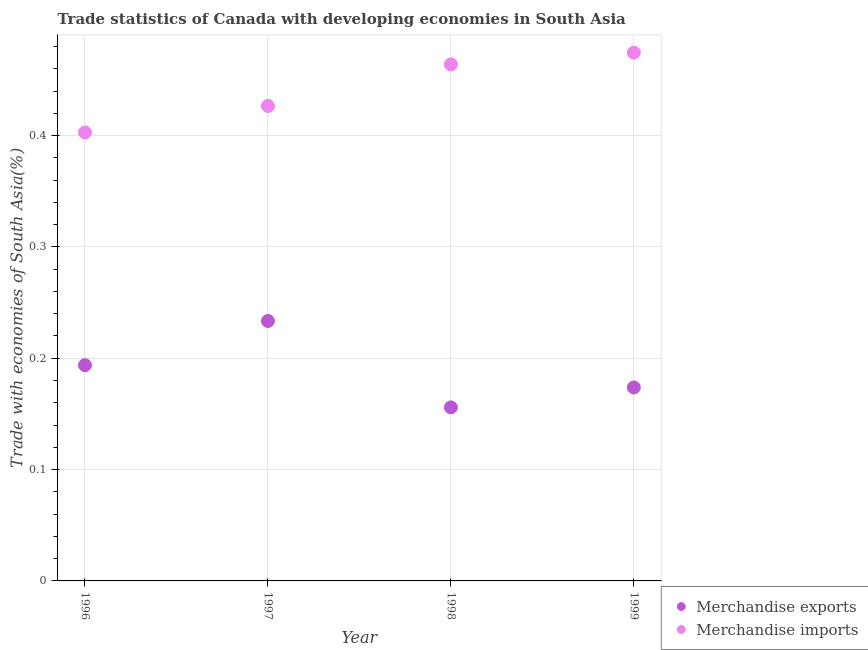Is the number of dotlines equal to the number of legend labels?
Provide a succinct answer. Yes. What is the merchandise exports in 1999?
Keep it short and to the point. 0.17. Across all years, what is the maximum merchandise imports?
Ensure brevity in your answer.  0.47. Across all years, what is the minimum merchandise exports?
Your answer should be very brief. 0.16. In which year was the merchandise exports maximum?
Your answer should be compact. 1997. What is the total merchandise imports in the graph?
Offer a terse response. 1.77. What is the difference between the merchandise exports in 1996 and that in 1997?
Your response must be concise. -0.04. What is the difference between the merchandise exports in 1996 and the merchandise imports in 1998?
Make the answer very short. -0.27. What is the average merchandise exports per year?
Offer a very short reply. 0.19. In the year 1999, what is the difference between the merchandise exports and merchandise imports?
Your response must be concise. -0.3. In how many years, is the merchandise imports greater than 0.22 %?
Provide a short and direct response. 4. What is the ratio of the merchandise exports in 1998 to that in 1999?
Provide a short and direct response. 0.9. Is the merchandise exports in 1996 less than that in 1998?
Make the answer very short. No. Is the difference between the merchandise imports in 1996 and 1997 greater than the difference between the merchandise exports in 1996 and 1997?
Provide a short and direct response. Yes. What is the difference between the highest and the second highest merchandise exports?
Ensure brevity in your answer.  0.04. What is the difference between the highest and the lowest merchandise exports?
Your answer should be compact. 0.08. Is the merchandise exports strictly greater than the merchandise imports over the years?
Ensure brevity in your answer.  No. Is the merchandise exports strictly less than the merchandise imports over the years?
Your answer should be very brief. Yes. How many dotlines are there?
Give a very brief answer. 2. Are the values on the major ticks of Y-axis written in scientific E-notation?
Offer a very short reply. No. Does the graph contain any zero values?
Offer a very short reply. No. Where does the legend appear in the graph?
Offer a terse response. Bottom right. How are the legend labels stacked?
Your response must be concise. Vertical. What is the title of the graph?
Offer a very short reply. Trade statistics of Canada with developing economies in South Asia. What is the label or title of the X-axis?
Give a very brief answer. Year. What is the label or title of the Y-axis?
Give a very brief answer. Trade with economies of South Asia(%). What is the Trade with economies of South Asia(%) in Merchandise exports in 1996?
Keep it short and to the point. 0.19. What is the Trade with economies of South Asia(%) of Merchandise imports in 1996?
Provide a short and direct response. 0.4. What is the Trade with economies of South Asia(%) in Merchandise exports in 1997?
Offer a terse response. 0.23. What is the Trade with economies of South Asia(%) of Merchandise imports in 1997?
Give a very brief answer. 0.43. What is the Trade with economies of South Asia(%) in Merchandise exports in 1998?
Make the answer very short. 0.16. What is the Trade with economies of South Asia(%) in Merchandise imports in 1998?
Keep it short and to the point. 0.46. What is the Trade with economies of South Asia(%) of Merchandise exports in 1999?
Give a very brief answer. 0.17. What is the Trade with economies of South Asia(%) of Merchandise imports in 1999?
Provide a succinct answer. 0.47. Across all years, what is the maximum Trade with economies of South Asia(%) of Merchandise exports?
Provide a short and direct response. 0.23. Across all years, what is the maximum Trade with economies of South Asia(%) in Merchandise imports?
Your answer should be very brief. 0.47. Across all years, what is the minimum Trade with economies of South Asia(%) of Merchandise exports?
Provide a succinct answer. 0.16. Across all years, what is the minimum Trade with economies of South Asia(%) of Merchandise imports?
Provide a succinct answer. 0.4. What is the total Trade with economies of South Asia(%) in Merchandise exports in the graph?
Your answer should be very brief. 0.76. What is the total Trade with economies of South Asia(%) in Merchandise imports in the graph?
Provide a short and direct response. 1.77. What is the difference between the Trade with economies of South Asia(%) of Merchandise exports in 1996 and that in 1997?
Give a very brief answer. -0.04. What is the difference between the Trade with economies of South Asia(%) in Merchandise imports in 1996 and that in 1997?
Your answer should be very brief. -0.02. What is the difference between the Trade with economies of South Asia(%) of Merchandise exports in 1996 and that in 1998?
Make the answer very short. 0.04. What is the difference between the Trade with economies of South Asia(%) in Merchandise imports in 1996 and that in 1998?
Your response must be concise. -0.06. What is the difference between the Trade with economies of South Asia(%) of Merchandise exports in 1996 and that in 1999?
Keep it short and to the point. 0.02. What is the difference between the Trade with economies of South Asia(%) of Merchandise imports in 1996 and that in 1999?
Provide a short and direct response. -0.07. What is the difference between the Trade with economies of South Asia(%) in Merchandise exports in 1997 and that in 1998?
Provide a succinct answer. 0.08. What is the difference between the Trade with economies of South Asia(%) in Merchandise imports in 1997 and that in 1998?
Provide a short and direct response. -0.04. What is the difference between the Trade with economies of South Asia(%) in Merchandise exports in 1997 and that in 1999?
Your answer should be very brief. 0.06. What is the difference between the Trade with economies of South Asia(%) of Merchandise imports in 1997 and that in 1999?
Provide a succinct answer. -0.05. What is the difference between the Trade with economies of South Asia(%) in Merchandise exports in 1998 and that in 1999?
Your answer should be compact. -0.02. What is the difference between the Trade with economies of South Asia(%) in Merchandise imports in 1998 and that in 1999?
Ensure brevity in your answer.  -0.01. What is the difference between the Trade with economies of South Asia(%) of Merchandise exports in 1996 and the Trade with economies of South Asia(%) of Merchandise imports in 1997?
Your response must be concise. -0.23. What is the difference between the Trade with economies of South Asia(%) of Merchandise exports in 1996 and the Trade with economies of South Asia(%) of Merchandise imports in 1998?
Your answer should be very brief. -0.27. What is the difference between the Trade with economies of South Asia(%) of Merchandise exports in 1996 and the Trade with economies of South Asia(%) of Merchandise imports in 1999?
Provide a succinct answer. -0.28. What is the difference between the Trade with economies of South Asia(%) of Merchandise exports in 1997 and the Trade with economies of South Asia(%) of Merchandise imports in 1998?
Your answer should be compact. -0.23. What is the difference between the Trade with economies of South Asia(%) in Merchandise exports in 1997 and the Trade with economies of South Asia(%) in Merchandise imports in 1999?
Provide a succinct answer. -0.24. What is the difference between the Trade with economies of South Asia(%) in Merchandise exports in 1998 and the Trade with economies of South Asia(%) in Merchandise imports in 1999?
Give a very brief answer. -0.32. What is the average Trade with economies of South Asia(%) in Merchandise exports per year?
Ensure brevity in your answer.  0.19. What is the average Trade with economies of South Asia(%) of Merchandise imports per year?
Your response must be concise. 0.44. In the year 1996, what is the difference between the Trade with economies of South Asia(%) in Merchandise exports and Trade with economies of South Asia(%) in Merchandise imports?
Your answer should be very brief. -0.21. In the year 1997, what is the difference between the Trade with economies of South Asia(%) of Merchandise exports and Trade with economies of South Asia(%) of Merchandise imports?
Offer a very short reply. -0.19. In the year 1998, what is the difference between the Trade with economies of South Asia(%) of Merchandise exports and Trade with economies of South Asia(%) of Merchandise imports?
Keep it short and to the point. -0.31. In the year 1999, what is the difference between the Trade with economies of South Asia(%) of Merchandise exports and Trade with economies of South Asia(%) of Merchandise imports?
Your answer should be compact. -0.3. What is the ratio of the Trade with economies of South Asia(%) of Merchandise exports in 1996 to that in 1997?
Your answer should be compact. 0.83. What is the ratio of the Trade with economies of South Asia(%) in Merchandise imports in 1996 to that in 1997?
Provide a short and direct response. 0.94. What is the ratio of the Trade with economies of South Asia(%) in Merchandise exports in 1996 to that in 1998?
Provide a short and direct response. 1.24. What is the ratio of the Trade with economies of South Asia(%) in Merchandise imports in 1996 to that in 1998?
Offer a very short reply. 0.87. What is the ratio of the Trade with economies of South Asia(%) of Merchandise exports in 1996 to that in 1999?
Ensure brevity in your answer.  1.12. What is the ratio of the Trade with economies of South Asia(%) of Merchandise imports in 1996 to that in 1999?
Keep it short and to the point. 0.85. What is the ratio of the Trade with economies of South Asia(%) in Merchandise exports in 1997 to that in 1998?
Ensure brevity in your answer.  1.5. What is the ratio of the Trade with economies of South Asia(%) of Merchandise imports in 1997 to that in 1998?
Keep it short and to the point. 0.92. What is the ratio of the Trade with economies of South Asia(%) in Merchandise exports in 1997 to that in 1999?
Your response must be concise. 1.34. What is the ratio of the Trade with economies of South Asia(%) in Merchandise imports in 1997 to that in 1999?
Give a very brief answer. 0.9. What is the ratio of the Trade with economies of South Asia(%) of Merchandise exports in 1998 to that in 1999?
Offer a very short reply. 0.9. What is the ratio of the Trade with economies of South Asia(%) of Merchandise imports in 1998 to that in 1999?
Make the answer very short. 0.98. What is the difference between the highest and the second highest Trade with economies of South Asia(%) of Merchandise exports?
Provide a succinct answer. 0.04. What is the difference between the highest and the second highest Trade with economies of South Asia(%) of Merchandise imports?
Give a very brief answer. 0.01. What is the difference between the highest and the lowest Trade with economies of South Asia(%) of Merchandise exports?
Ensure brevity in your answer.  0.08. What is the difference between the highest and the lowest Trade with economies of South Asia(%) in Merchandise imports?
Your answer should be very brief. 0.07. 